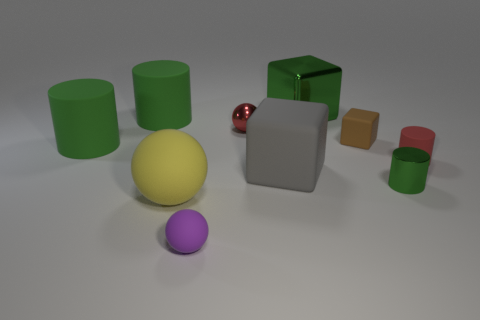Subtract all purple spheres. How many green cylinders are left? 3 Subtract all cylinders. How many objects are left? 6 Subtract all tiny rubber cylinders. Subtract all rubber things. How many objects are left? 2 Add 6 shiny cubes. How many shiny cubes are left? 7 Add 8 large cylinders. How many large cylinders exist? 10 Subtract 1 green cubes. How many objects are left? 9 